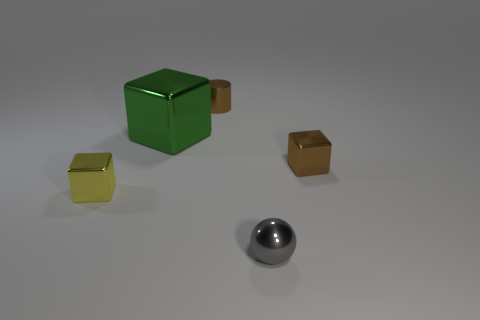Subtract all small metal blocks. How many blocks are left? 1 Subtract all cylinders. How many objects are left? 4 Add 2 tiny brown metallic objects. How many tiny brown metallic objects are left? 4 Add 1 small purple metal cubes. How many small purple metal cubes exist? 1 Add 4 purple things. How many objects exist? 9 Subtract 0 purple cylinders. How many objects are left? 5 Subtract 1 blocks. How many blocks are left? 2 Subtract all gray cylinders. Subtract all purple spheres. How many cylinders are left? 1 Subtract all gray balls. How many blue cubes are left? 0 Subtract all purple things. Subtract all brown metal objects. How many objects are left? 3 